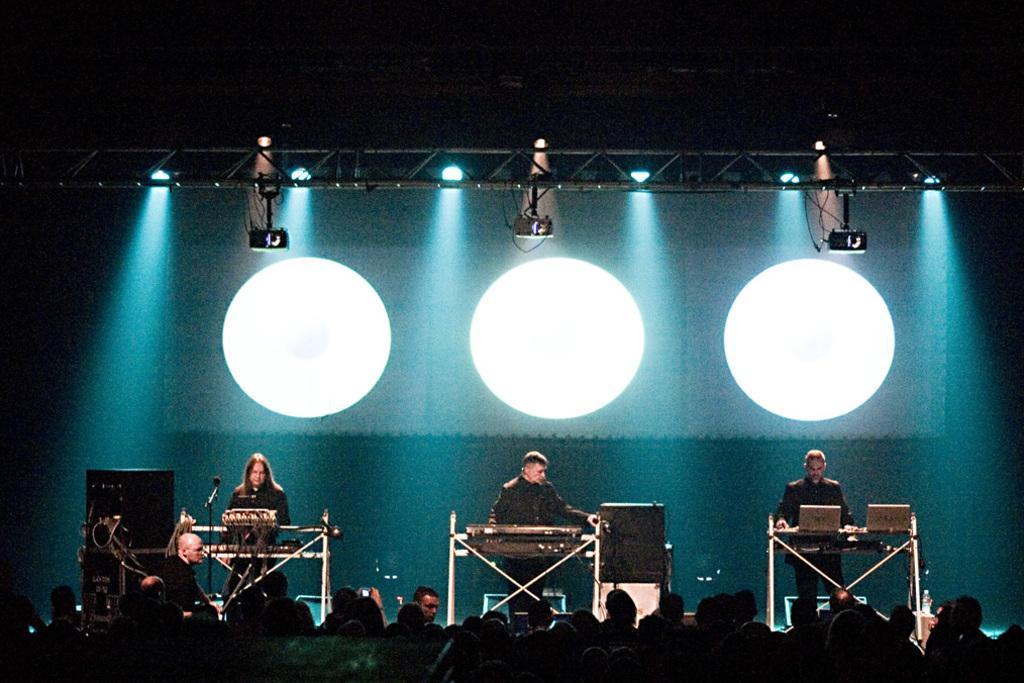In one or two sentences, can you explain what this image depicts? In this image I can see three persons are standing on the stage and playing some musical instruments. At the back of the people I can see a board. At the top there are some lights attached to a metal rod. On the left side, I can see a speaker which is placed on the stage. At the bottom of the image I can see many people are facing towards the stage. 